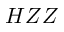Convert formula to latex. <formula><loc_0><loc_0><loc_500><loc_500>H Z Z</formula> 